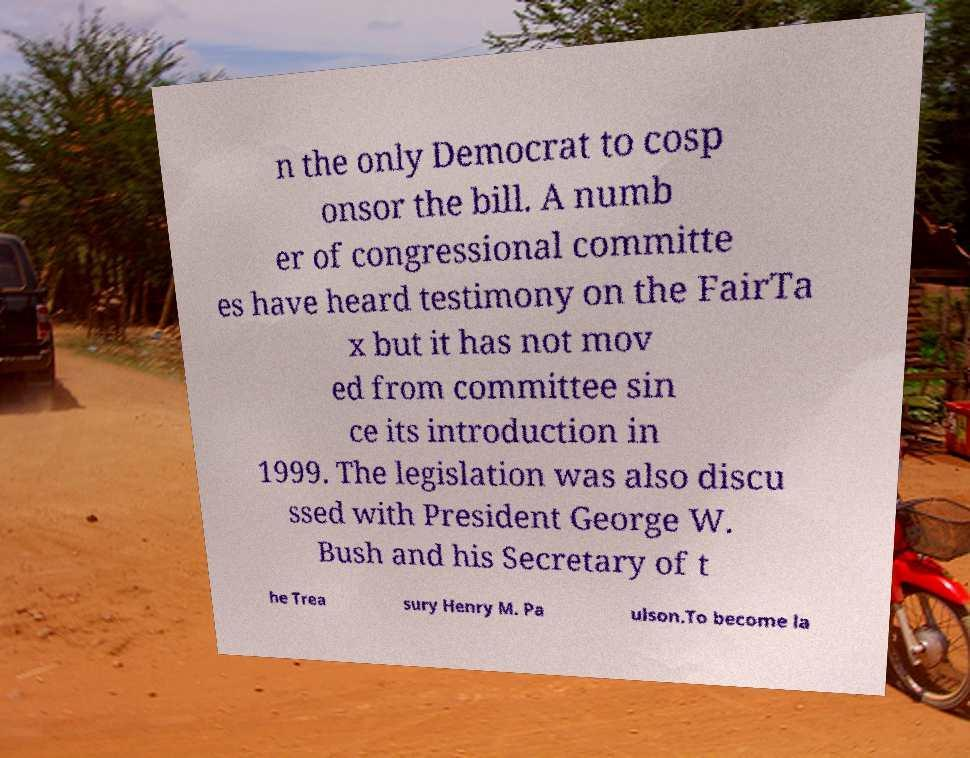What messages or text are displayed in this image? I need them in a readable, typed format. n the only Democrat to cosp onsor the bill. A numb er of congressional committe es have heard testimony on the FairTa x but it has not mov ed from committee sin ce its introduction in 1999. The legislation was also discu ssed with President George W. Bush and his Secretary of t he Trea sury Henry M. Pa ulson.To become la 